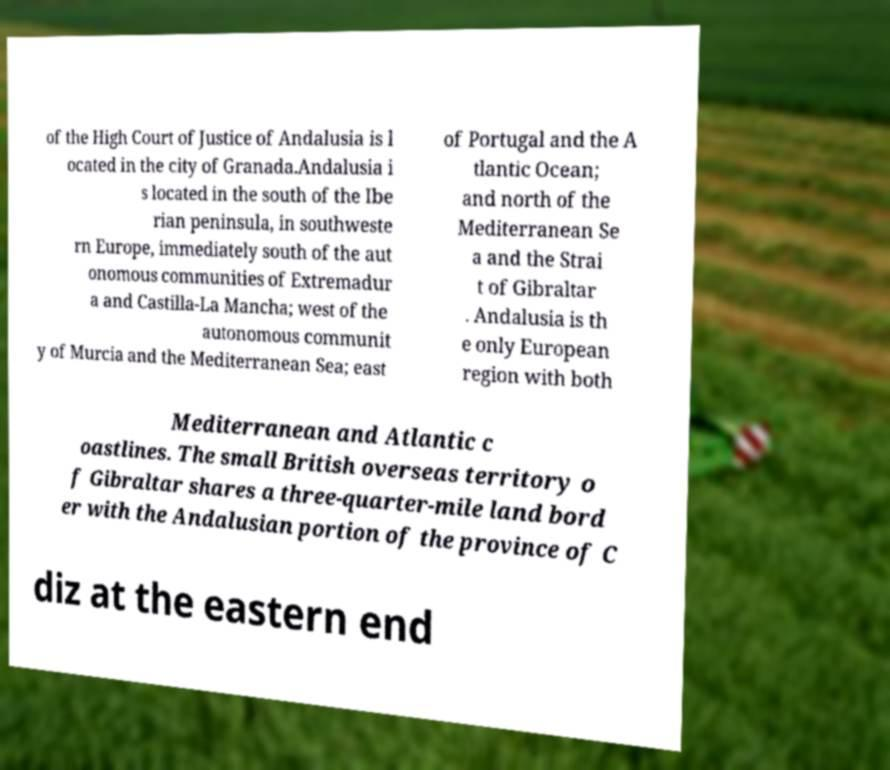For documentation purposes, I need the text within this image transcribed. Could you provide that? of the High Court of Justice of Andalusia is l ocated in the city of Granada.Andalusia i s located in the south of the Ibe rian peninsula, in southweste rn Europe, immediately south of the aut onomous communities of Extremadur a and Castilla-La Mancha; west of the autonomous communit y of Murcia and the Mediterranean Sea; east of Portugal and the A tlantic Ocean; and north of the Mediterranean Se a and the Strai t of Gibraltar . Andalusia is th e only European region with both Mediterranean and Atlantic c oastlines. The small British overseas territory o f Gibraltar shares a three-quarter-mile land bord er with the Andalusian portion of the province of C diz at the eastern end 